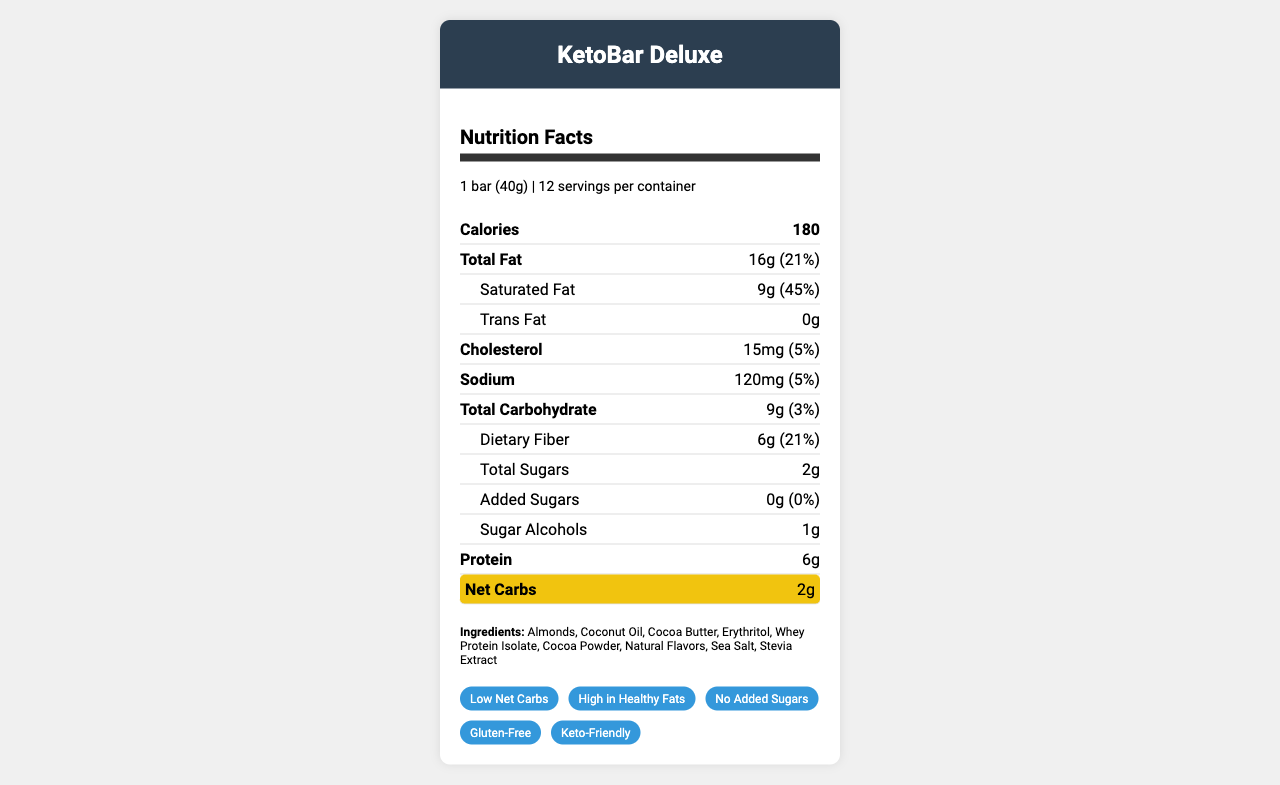what is the serving size for KetoBar Deluxe? The document states that the serving size is "1 bar (40g)".
Answer: 1 bar (40g) how many servings are there in a container of KetoBar Deluxe? The document indicates that there are 12 servings per container.
Answer: 12 what is the total fat content per serving? The nutrient row labeled "Total Fat" shows that there are 16 grams of fat per serving.
Answer: 16g what is the net carb content per serving? The highlighted nutrient row labeled "Net Carbs" shows that there are 2 grams of net carbs per serving.
Answer: 2g how much dietary fiber is in one serving? The nutrient row under "Total Carbohydrate" lists "Dietary Fiber" as 6 grams per serving.
Answer: 6g does the KetoBar Deluxe contain any added sugars? The document states that the amount of added sugars is 0 grams.
Answer: No which of the following is not listed as an ingredient in KetoBar Deluxe? A. Almonds B. Cocoa Butter C. Soy Protein D. Stevia Extract The ingredients list includes almonds, cocoa butter, and stevia extract but does not mention soy protein.
Answer: C how many grams of saturated fat does each serving contain? A. 4g B. 6g C. 9g D. 12g The document shows that each serving contains 9 grams of saturated fat.
Answer: C which feature is highlighted on the KetoBar Deluxe? A. High in Protein B. Low Net Carbs C. Organic Ingredients D. Vegan The highlight section lists "Low Net Carbs" as a key feature.
Answer: B is the product gluten-free? The key features section contains the attribute "Gluten-Free".
Answer: Yes summarize the main nutritional features of KetoBar Deluxe. The document highlights the key nutritional features including low net carbs (2g), high fat content (16g total fat with 9g saturated fat), and no added sugars. It also mentions that it provides 6g of protein per serving and is described as keto-friendly and gluten-free.
Answer: KetoBar Deluxe is a keto-friendly snack bar with low net carbs (2g) and high fat content (16g), including 9g of saturated fat, containing no added sugars, and providing 6g of protein per serving. what is the daily value percentage for total carbohydrates per serving? The nutrient row labeled "Total Carbohydrate" shows a daily value of 3%.
Answer: 3% who is the manufacturer of KetoBar Deluxe, and what is their contact email? The manufacturer information at the bottom of the document lists KetoNutrition Inc. as the manufacturer and provides the contact email as info@ketobardeluxe.com.
Answer: KetoNutrition Inc., info@ketobardeluxe.com where is KetoBar Deluxe manufactured? The document does not specify the location of the manufacturing facility, only the address of the manufacturer.
Answer: Cannot be determined what is the calorie count of one KetoBar Deluxe bar? The nutrient row labeled "Calories" shows that each bar contains 180 calories.
Answer: 180 how much sodium does each serving contain? The nutrient row labeled "Sodium" shows that each serving contains 120mg of sodium.
Answer: 120mg 